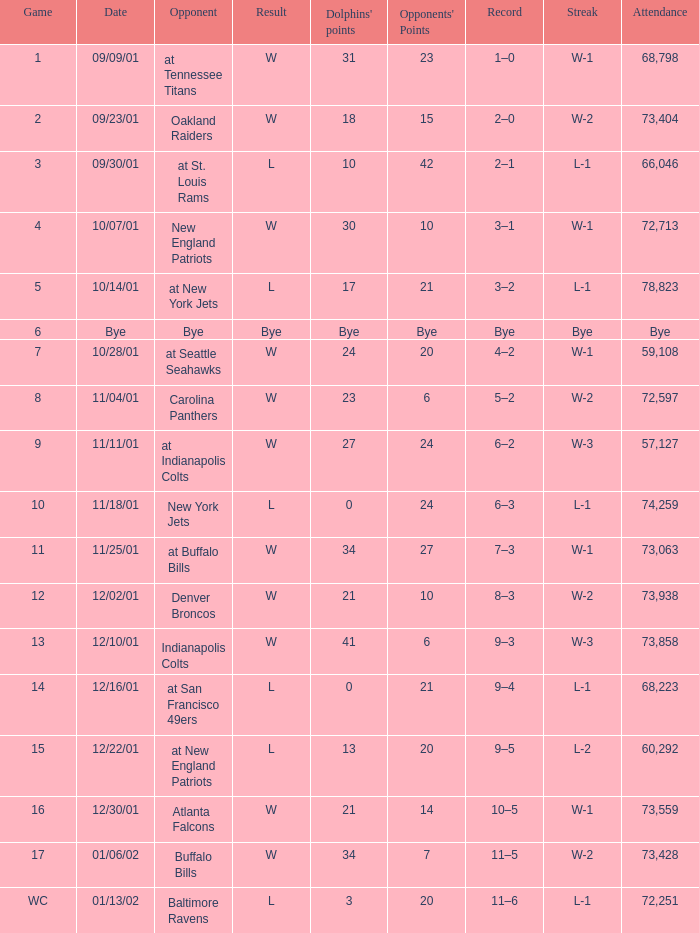What is the ongoing win sequence for game number 2? W-2. 